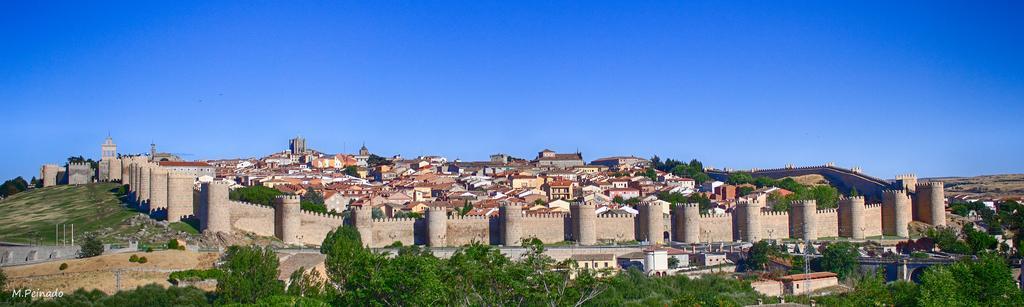Please provide a concise description of this image. In this image there is the sky towards the top of the image, there are buildings, there is a wall, there are poles, there are plants towards the bottom of the image, there is text towards the bottom of the image. 